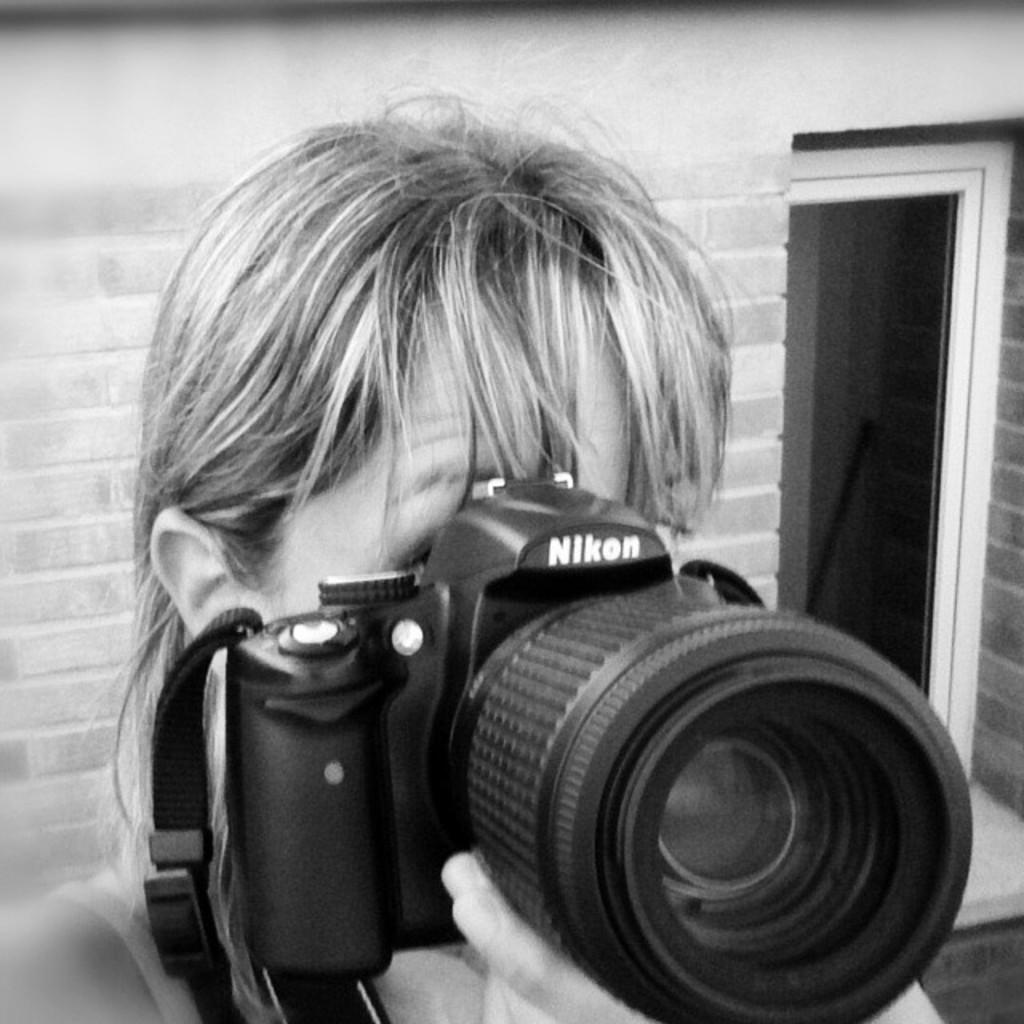Who is the main subject in the image? There is a girl in the image. What is the girl holding in the image? The girl is holding a camera. Can you identify the brand of the camera? Yes, the camera has the text "Nikon" on it. What can be seen in the background of the image? There is a brick wall in the background of the image. What type of animal can be seen sitting on the boat in the image? There is no boat or animal present in the image. What is the girl using to drink from the cup in the image? There is no cup present in the image. 